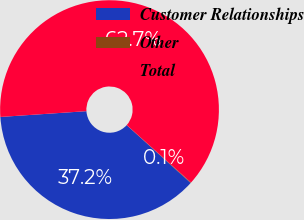Convert chart to OTSL. <chart><loc_0><loc_0><loc_500><loc_500><pie_chart><fcel>Customer Relationships<fcel>Other<fcel>Total<nl><fcel>37.24%<fcel>0.08%<fcel>62.68%<nl></chart> 